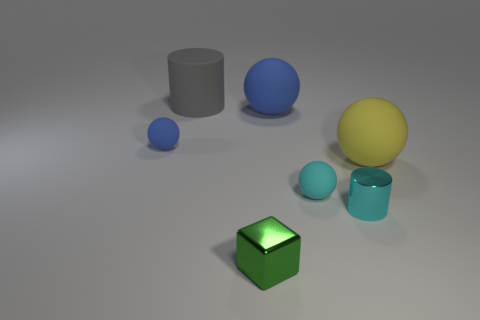Do the matte thing that is behind the big blue rubber thing and the tiny cube have the same color?
Keep it short and to the point. No. There is a small object that is the same color as the metal cylinder; what is its shape?
Make the answer very short. Sphere. What number of cyan balls are the same material as the small blue thing?
Your answer should be compact. 1. How many yellow rubber balls are behind the small cyan shiny cylinder?
Keep it short and to the point. 1. What size is the matte cylinder?
Provide a short and direct response. Large. There is a block that is the same size as the cyan shiny thing; what is its color?
Offer a terse response. Green. Is there a large matte ball of the same color as the small cylinder?
Your answer should be compact. No. What is the material of the yellow ball?
Offer a terse response. Rubber. What number of tiny cyan metallic cylinders are there?
Give a very brief answer. 1. There is a tiny object in front of the small cyan metallic cylinder; does it have the same color as the object left of the big gray object?
Give a very brief answer. No. 